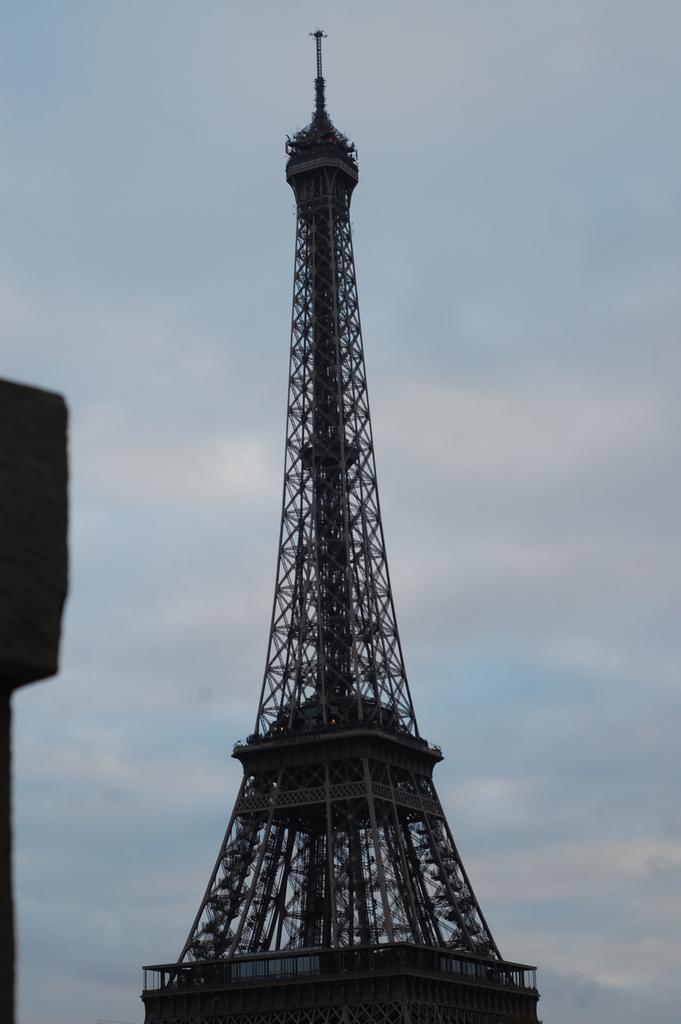What famous landmark can be seen in the image? The Eiffel Tower is present in the image. What part of the natural environment is visible in the image? The sky is visible in the image. How many jellyfish can be seen swimming in the sky in the image? There are no jellyfish present in the image, as it features the Eiffel Tower and the sky. 